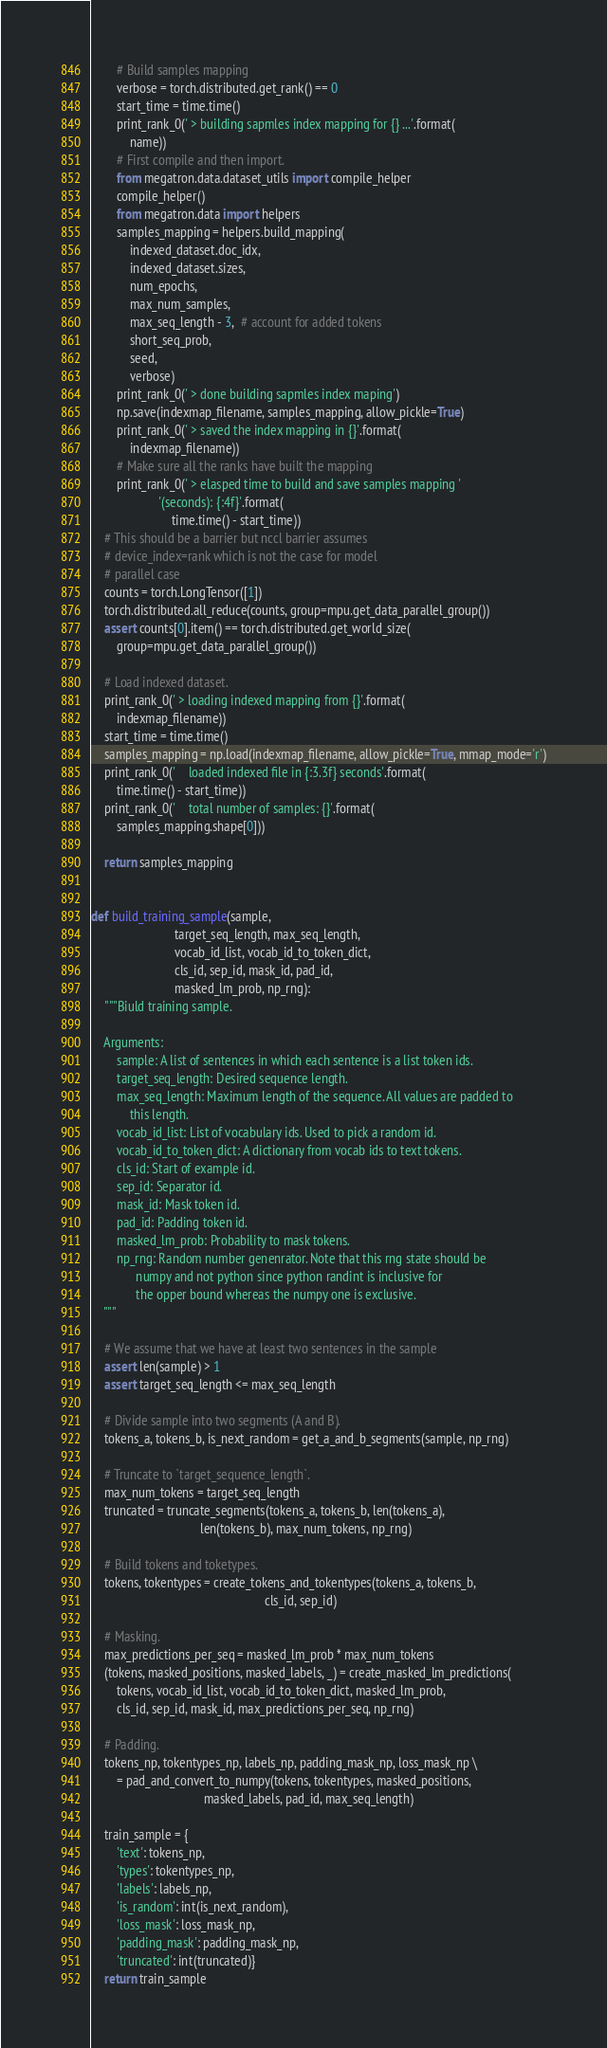Convert code to text. <code><loc_0><loc_0><loc_500><loc_500><_Python_>        # Build samples mapping
        verbose = torch.distributed.get_rank() == 0
        start_time = time.time()
        print_rank_0(' > building sapmles index mapping for {} ...'.format(
            name))
        # First compile and then import.
        from megatron.data.dataset_utils import compile_helper
        compile_helper()
        from megatron.data import helpers
        samples_mapping = helpers.build_mapping(
            indexed_dataset.doc_idx,
            indexed_dataset.sizes,
            num_epochs,
            max_num_samples,
            max_seq_length - 3,  # account for added tokens
            short_seq_prob,
            seed,
            verbose)
        print_rank_0(' > done building sapmles index maping')
        np.save(indexmap_filename, samples_mapping, allow_pickle=True)
        print_rank_0(' > saved the index mapping in {}'.format(
            indexmap_filename))
        # Make sure all the ranks have built the mapping
        print_rank_0(' > elasped time to build and save samples mapping '
                     '(seconds): {:4f}'.format(
                         time.time() - start_time))
    # This should be a barrier but nccl barrier assumes
    # device_index=rank which is not the case for model
    # parallel case
    counts = torch.LongTensor([1])
    torch.distributed.all_reduce(counts, group=mpu.get_data_parallel_group())
    assert counts[0].item() == torch.distributed.get_world_size(
        group=mpu.get_data_parallel_group())

    # Load indexed dataset.
    print_rank_0(' > loading indexed mapping from {}'.format(
        indexmap_filename))
    start_time = time.time()
    samples_mapping = np.load(indexmap_filename, allow_pickle=True, mmap_mode='r')
    print_rank_0('    loaded indexed file in {:3.3f} seconds'.format(
        time.time() - start_time))
    print_rank_0('    total number of samples: {}'.format(
        samples_mapping.shape[0]))

    return samples_mapping


def build_training_sample(sample,
                          target_seq_length, max_seq_length,
                          vocab_id_list, vocab_id_to_token_dict,
                          cls_id, sep_id, mask_id, pad_id,
                          masked_lm_prob, np_rng):
    """Biuld training sample.

    Arguments:
        sample: A list of sentences in which each sentence is a list token ids.
        target_seq_length: Desired sequence length.
        max_seq_length: Maximum length of the sequence. All values are padded to
            this length.
        vocab_id_list: List of vocabulary ids. Used to pick a random id.
        vocab_id_to_token_dict: A dictionary from vocab ids to text tokens.
        cls_id: Start of example id.
        sep_id: Separator id.
        mask_id: Mask token id.
        pad_id: Padding token id.
        masked_lm_prob: Probability to mask tokens.
        np_rng: Random number genenrator. Note that this rng state should be
              numpy and not python since python randint is inclusive for
              the opper bound whereas the numpy one is exclusive.
    """

    # We assume that we have at least two sentences in the sample
    assert len(sample) > 1
    assert target_seq_length <= max_seq_length

    # Divide sample into two segments (A and B).
    tokens_a, tokens_b, is_next_random = get_a_and_b_segments(sample, np_rng)

    # Truncate to `target_sequence_length`.
    max_num_tokens = target_seq_length
    truncated = truncate_segments(tokens_a, tokens_b, len(tokens_a),
                                  len(tokens_b), max_num_tokens, np_rng)

    # Build tokens and toketypes.
    tokens, tokentypes = create_tokens_and_tokentypes(tokens_a, tokens_b,
                                                      cls_id, sep_id)

    # Masking.
    max_predictions_per_seq = masked_lm_prob * max_num_tokens
    (tokens, masked_positions, masked_labels, _) = create_masked_lm_predictions(
        tokens, vocab_id_list, vocab_id_to_token_dict, masked_lm_prob,
        cls_id, sep_id, mask_id, max_predictions_per_seq, np_rng)

    # Padding.
    tokens_np, tokentypes_np, labels_np, padding_mask_np, loss_mask_np \
        = pad_and_convert_to_numpy(tokens, tokentypes, masked_positions,
                                   masked_labels, pad_id, max_seq_length)

    train_sample = {
        'text': tokens_np,
        'types': tokentypes_np,
        'labels': labels_np,
        'is_random': int(is_next_random),
        'loss_mask': loss_mask_np,
        'padding_mask': padding_mask_np,
        'truncated': int(truncated)}
    return train_sample

</code> 